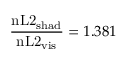<formula> <loc_0><loc_0><loc_500><loc_500>\frac { n L 2 _ { s h a d } } { n L 2 _ { v i s } } = 1 . 3 8 1</formula> 